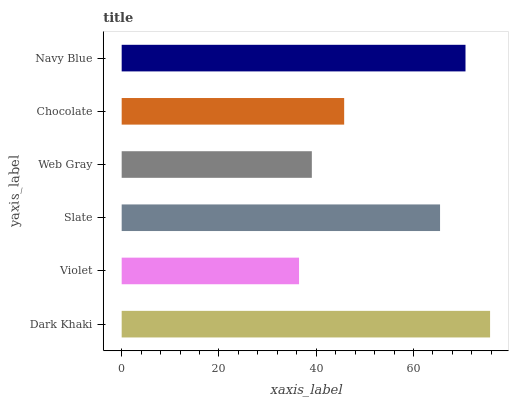Is Violet the minimum?
Answer yes or no. Yes. Is Dark Khaki the maximum?
Answer yes or no. Yes. Is Slate the minimum?
Answer yes or no. No. Is Slate the maximum?
Answer yes or no. No. Is Slate greater than Violet?
Answer yes or no. Yes. Is Violet less than Slate?
Answer yes or no. Yes. Is Violet greater than Slate?
Answer yes or no. No. Is Slate less than Violet?
Answer yes or no. No. Is Slate the high median?
Answer yes or no. Yes. Is Chocolate the low median?
Answer yes or no. Yes. Is Navy Blue the high median?
Answer yes or no. No. Is Navy Blue the low median?
Answer yes or no. No. 